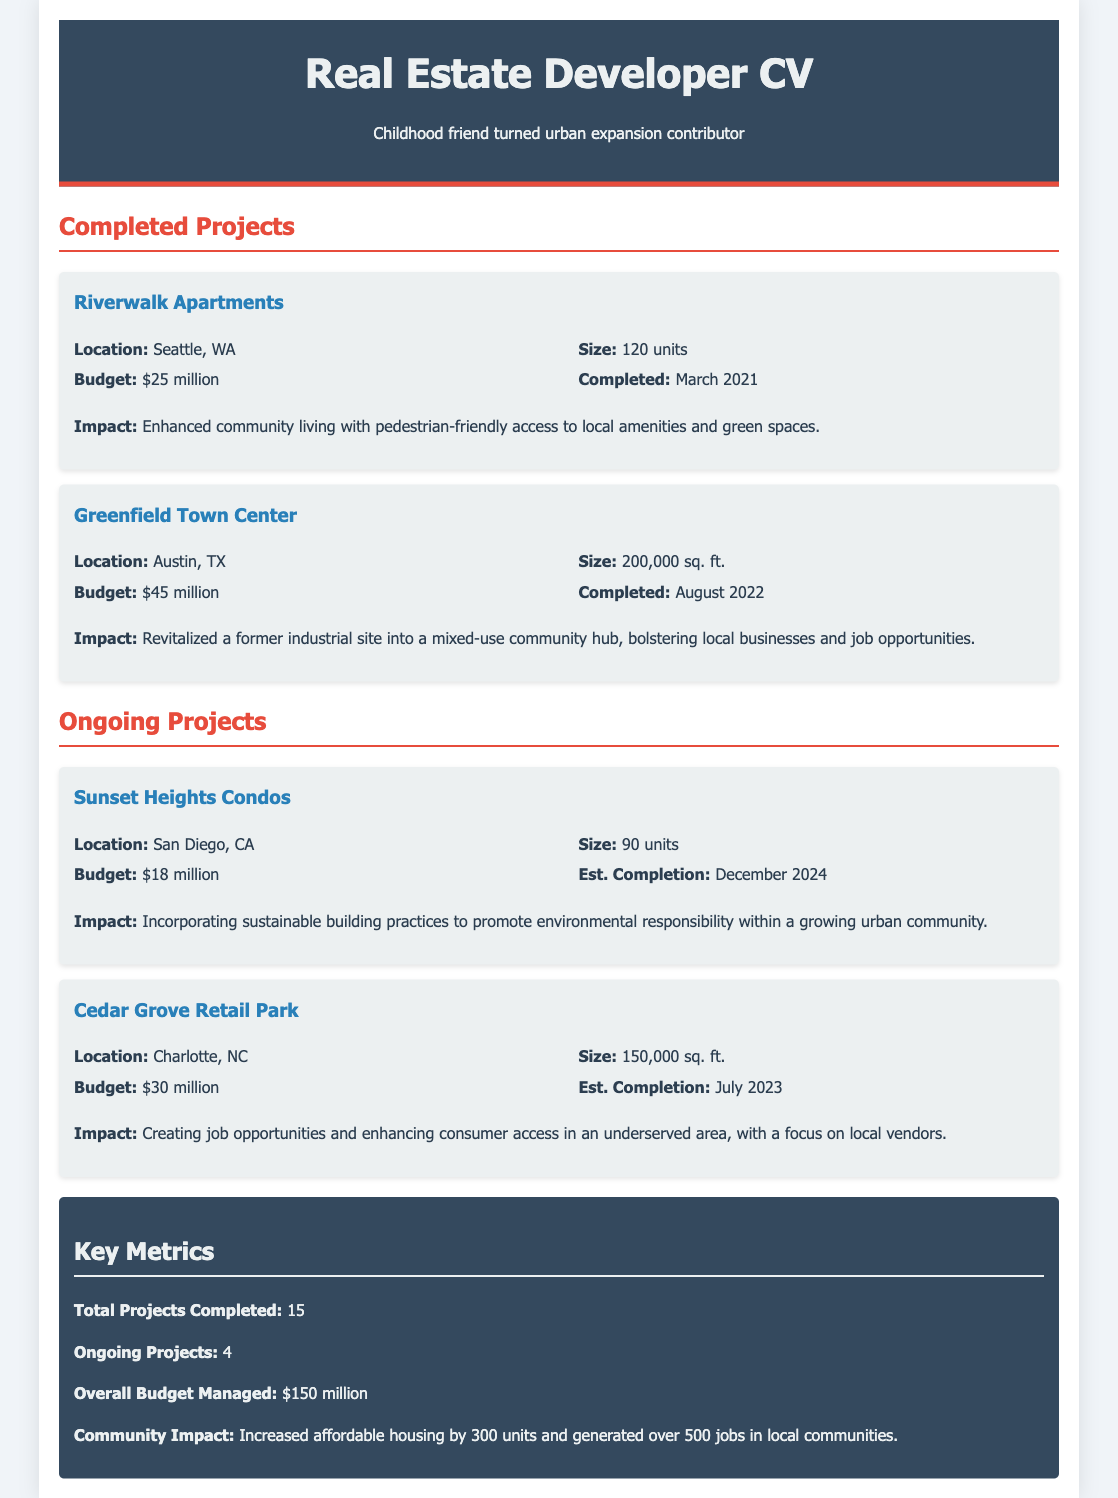What is the total number of completed projects? The document states that there are a total of 15 projects completed.
Answer: 15 What is the budget for the Greenfield Town Center? The budget for the Greenfield Town Center project is detailed in the document as $45 million.
Answer: $45 million What is the estimated completion date for the Sunset Heights Condos? The estimated completion date for the Sunset Heights Condos is mentioned as December 2024.
Answer: December 2024 What is the total budget managed across all projects? The document indicates that the overall budget managed is $150 million.
Answer: $150 million What was the impact of the Riverwalk Apartments project? The document notes that the impact of the Riverwalk Apartments was to enhance community living with pedestrian-friendly access.
Answer: Enhanced community living How many affordable housing units were increased according to the metrics? The document specifies that affordable housing was increased by 300 units.
Answer: 300 units What is the location of the Cedar Grove Retail Park? The document lists Charlotte, NC as the location for the Cedar Grove Retail Park.
Answer: Charlotte, NC What type of project is the Greenfield Town Center? The document describes the Greenfield Town Center as a mixed-use community hub.
Answer: Mixed-use community hub 